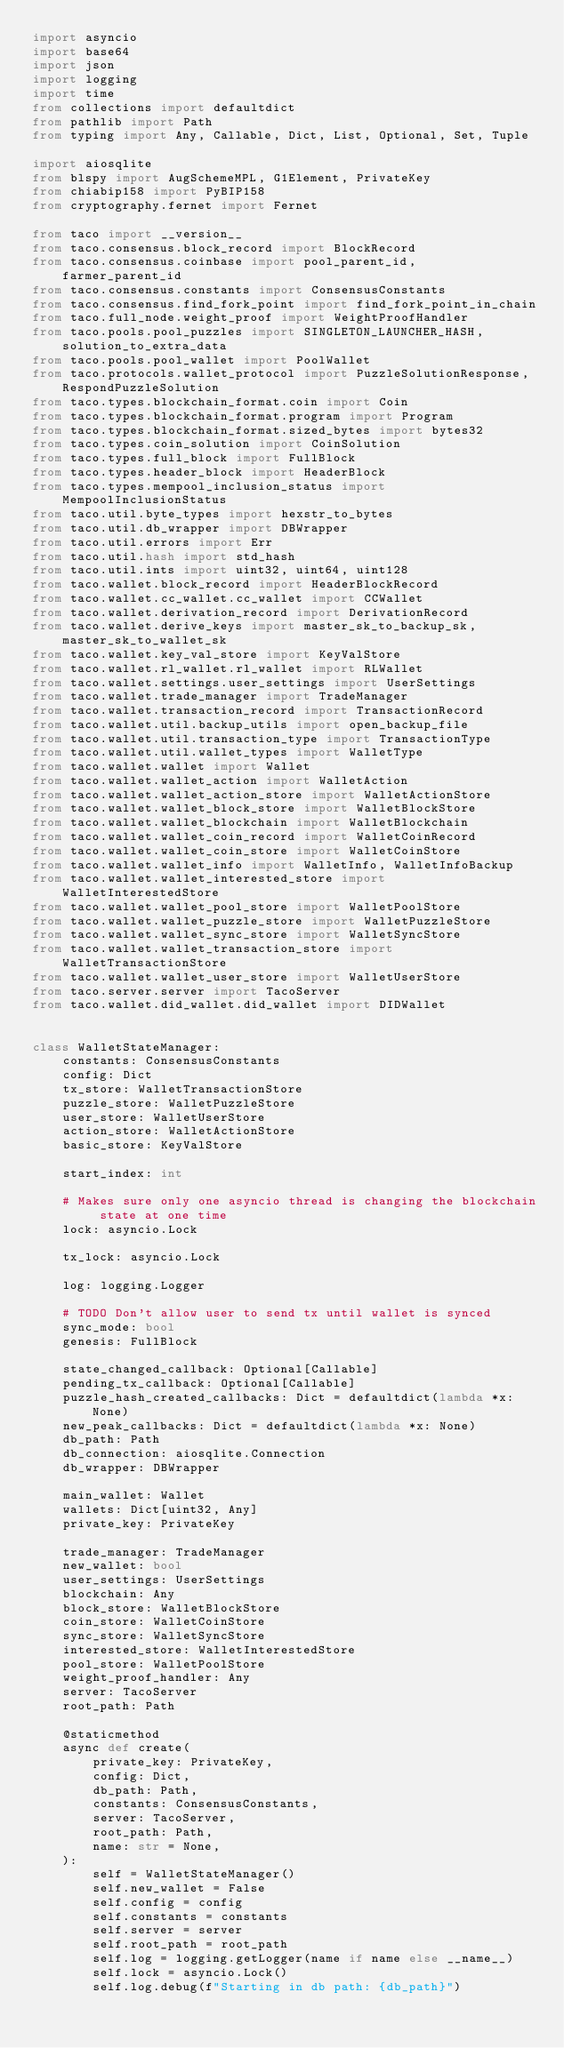Convert code to text. <code><loc_0><loc_0><loc_500><loc_500><_Python_>import asyncio
import base64
import json
import logging
import time
from collections import defaultdict
from pathlib import Path
from typing import Any, Callable, Dict, List, Optional, Set, Tuple

import aiosqlite
from blspy import AugSchemeMPL, G1Element, PrivateKey
from chiabip158 import PyBIP158
from cryptography.fernet import Fernet

from taco import __version__
from taco.consensus.block_record import BlockRecord
from taco.consensus.coinbase import pool_parent_id, farmer_parent_id
from taco.consensus.constants import ConsensusConstants
from taco.consensus.find_fork_point import find_fork_point_in_chain
from taco.full_node.weight_proof import WeightProofHandler
from taco.pools.pool_puzzles import SINGLETON_LAUNCHER_HASH, solution_to_extra_data
from taco.pools.pool_wallet import PoolWallet
from taco.protocols.wallet_protocol import PuzzleSolutionResponse, RespondPuzzleSolution
from taco.types.blockchain_format.coin import Coin
from taco.types.blockchain_format.program import Program
from taco.types.blockchain_format.sized_bytes import bytes32
from taco.types.coin_solution import CoinSolution
from taco.types.full_block import FullBlock
from taco.types.header_block import HeaderBlock
from taco.types.mempool_inclusion_status import MempoolInclusionStatus
from taco.util.byte_types import hexstr_to_bytes
from taco.util.db_wrapper import DBWrapper
from taco.util.errors import Err
from taco.util.hash import std_hash
from taco.util.ints import uint32, uint64, uint128
from taco.wallet.block_record import HeaderBlockRecord
from taco.wallet.cc_wallet.cc_wallet import CCWallet
from taco.wallet.derivation_record import DerivationRecord
from taco.wallet.derive_keys import master_sk_to_backup_sk, master_sk_to_wallet_sk
from taco.wallet.key_val_store import KeyValStore
from taco.wallet.rl_wallet.rl_wallet import RLWallet
from taco.wallet.settings.user_settings import UserSettings
from taco.wallet.trade_manager import TradeManager
from taco.wallet.transaction_record import TransactionRecord
from taco.wallet.util.backup_utils import open_backup_file
from taco.wallet.util.transaction_type import TransactionType
from taco.wallet.util.wallet_types import WalletType
from taco.wallet.wallet import Wallet
from taco.wallet.wallet_action import WalletAction
from taco.wallet.wallet_action_store import WalletActionStore
from taco.wallet.wallet_block_store import WalletBlockStore
from taco.wallet.wallet_blockchain import WalletBlockchain
from taco.wallet.wallet_coin_record import WalletCoinRecord
from taco.wallet.wallet_coin_store import WalletCoinStore
from taco.wallet.wallet_info import WalletInfo, WalletInfoBackup
from taco.wallet.wallet_interested_store import WalletInterestedStore
from taco.wallet.wallet_pool_store import WalletPoolStore
from taco.wallet.wallet_puzzle_store import WalletPuzzleStore
from taco.wallet.wallet_sync_store import WalletSyncStore
from taco.wallet.wallet_transaction_store import WalletTransactionStore
from taco.wallet.wallet_user_store import WalletUserStore
from taco.server.server import TacoServer
from taco.wallet.did_wallet.did_wallet import DIDWallet


class WalletStateManager:
    constants: ConsensusConstants
    config: Dict
    tx_store: WalletTransactionStore
    puzzle_store: WalletPuzzleStore
    user_store: WalletUserStore
    action_store: WalletActionStore
    basic_store: KeyValStore

    start_index: int

    # Makes sure only one asyncio thread is changing the blockchain state at one time
    lock: asyncio.Lock

    tx_lock: asyncio.Lock

    log: logging.Logger

    # TODO Don't allow user to send tx until wallet is synced
    sync_mode: bool
    genesis: FullBlock

    state_changed_callback: Optional[Callable]
    pending_tx_callback: Optional[Callable]
    puzzle_hash_created_callbacks: Dict = defaultdict(lambda *x: None)
    new_peak_callbacks: Dict = defaultdict(lambda *x: None)
    db_path: Path
    db_connection: aiosqlite.Connection
    db_wrapper: DBWrapper

    main_wallet: Wallet
    wallets: Dict[uint32, Any]
    private_key: PrivateKey

    trade_manager: TradeManager
    new_wallet: bool
    user_settings: UserSettings
    blockchain: Any
    block_store: WalletBlockStore
    coin_store: WalletCoinStore
    sync_store: WalletSyncStore
    interested_store: WalletInterestedStore
    pool_store: WalletPoolStore
    weight_proof_handler: Any
    server: TacoServer
    root_path: Path

    @staticmethod
    async def create(
        private_key: PrivateKey,
        config: Dict,
        db_path: Path,
        constants: ConsensusConstants,
        server: TacoServer,
        root_path: Path,
        name: str = None,
    ):
        self = WalletStateManager()
        self.new_wallet = False
        self.config = config
        self.constants = constants
        self.server = server
        self.root_path = root_path
        self.log = logging.getLogger(name if name else __name__)
        self.lock = asyncio.Lock()
        self.log.debug(f"Starting in db path: {db_path}")</code> 